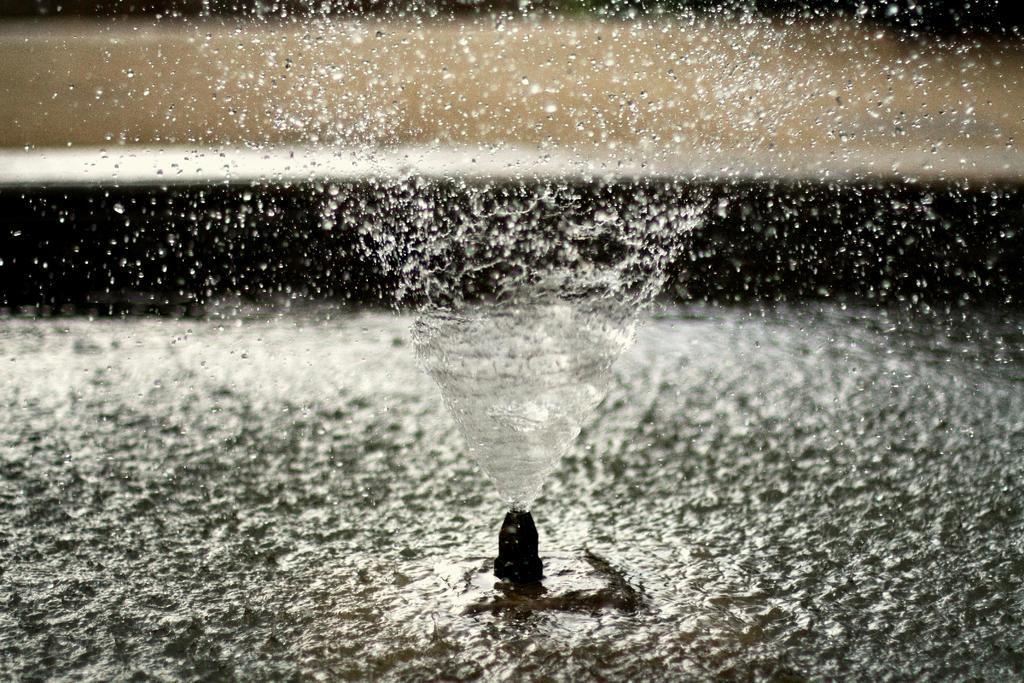Describe this image in one or two sentences. In this picture we can see water from a sprinkler. 